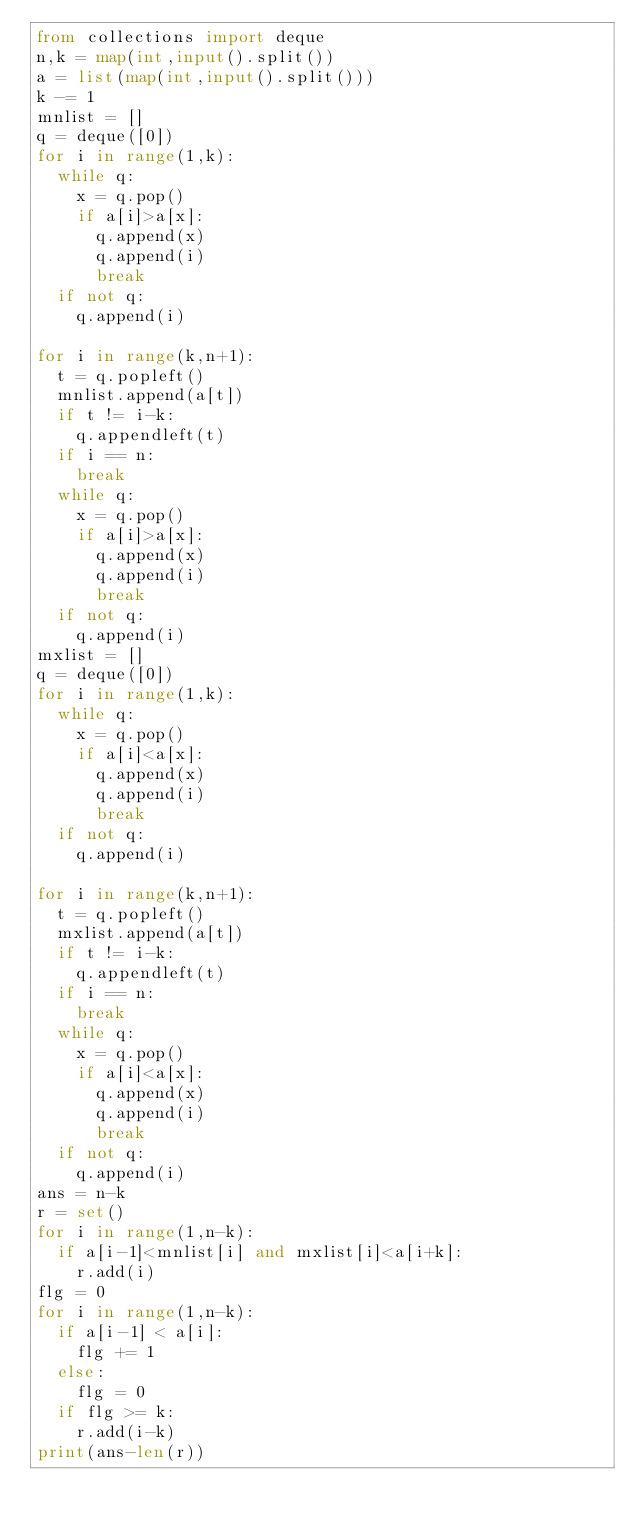<code> <loc_0><loc_0><loc_500><loc_500><_Python_>from collections import deque
n,k = map(int,input().split())
a = list(map(int,input().split()))
k -= 1
mnlist = []
q = deque([0])
for i in range(1,k):
  while q:
    x = q.pop()
    if a[i]>a[x]:
      q.append(x)
      q.append(i)
      break
  if not q:
    q.append(i)

for i in range(k,n+1):
  t = q.popleft()
  mnlist.append(a[t])
  if t != i-k:
    q.appendleft(t)
  if i == n:
    break
  while q:
    x = q.pop()
    if a[i]>a[x]:
      q.append(x)
      q.append(i)
      break
  if not q:
    q.append(i)
mxlist = []
q = deque([0])
for i in range(1,k):
  while q:
    x = q.pop()
    if a[i]<a[x]:
      q.append(x)
      q.append(i)
      break
  if not q:
    q.append(i)

for i in range(k,n+1):
  t = q.popleft()
  mxlist.append(a[t])
  if t != i-k:
    q.appendleft(t)
  if i == n:
    break
  while q:
    x = q.pop()
    if a[i]<a[x]:
      q.append(x)
      q.append(i)
      break
  if not q:
    q.append(i)
ans = n-k
r = set()
for i in range(1,n-k):
  if a[i-1]<mnlist[i] and mxlist[i]<a[i+k]:
    r.add(i)
flg = 0
for i in range(1,n-k):
  if a[i-1] < a[i]:
    flg += 1
  else:
    flg = 0
  if flg >= k:
    r.add(i-k)
print(ans-len(r))</code> 